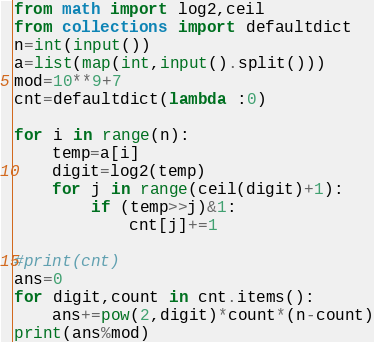<code> <loc_0><loc_0><loc_500><loc_500><_Python_>from math import log2,ceil
from collections import defaultdict
n=int(input())
a=list(map(int,input().split()))
mod=10**9+7
cnt=defaultdict(lambda :0)

for i in range(n):
    temp=a[i]
    digit=log2(temp)
    for j in range(ceil(digit)+1):
        if (temp>>j)&1:
            cnt[j]+=1

#print(cnt)
ans=0
for digit,count in cnt.items():
    ans+=pow(2,digit)*count*(n-count)
print(ans%mod)</code> 